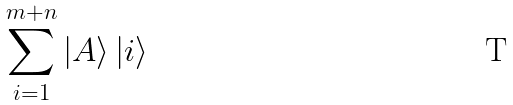Convert formula to latex. <formula><loc_0><loc_0><loc_500><loc_500>\sum _ { i = 1 } ^ { m + n } | A \rangle \, | i \rangle</formula> 